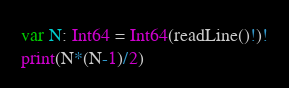<code> <loc_0><loc_0><loc_500><loc_500><_Swift_>var N: Int64 = Int64(readLine()!)!
print(N*(N-1)/2)</code> 